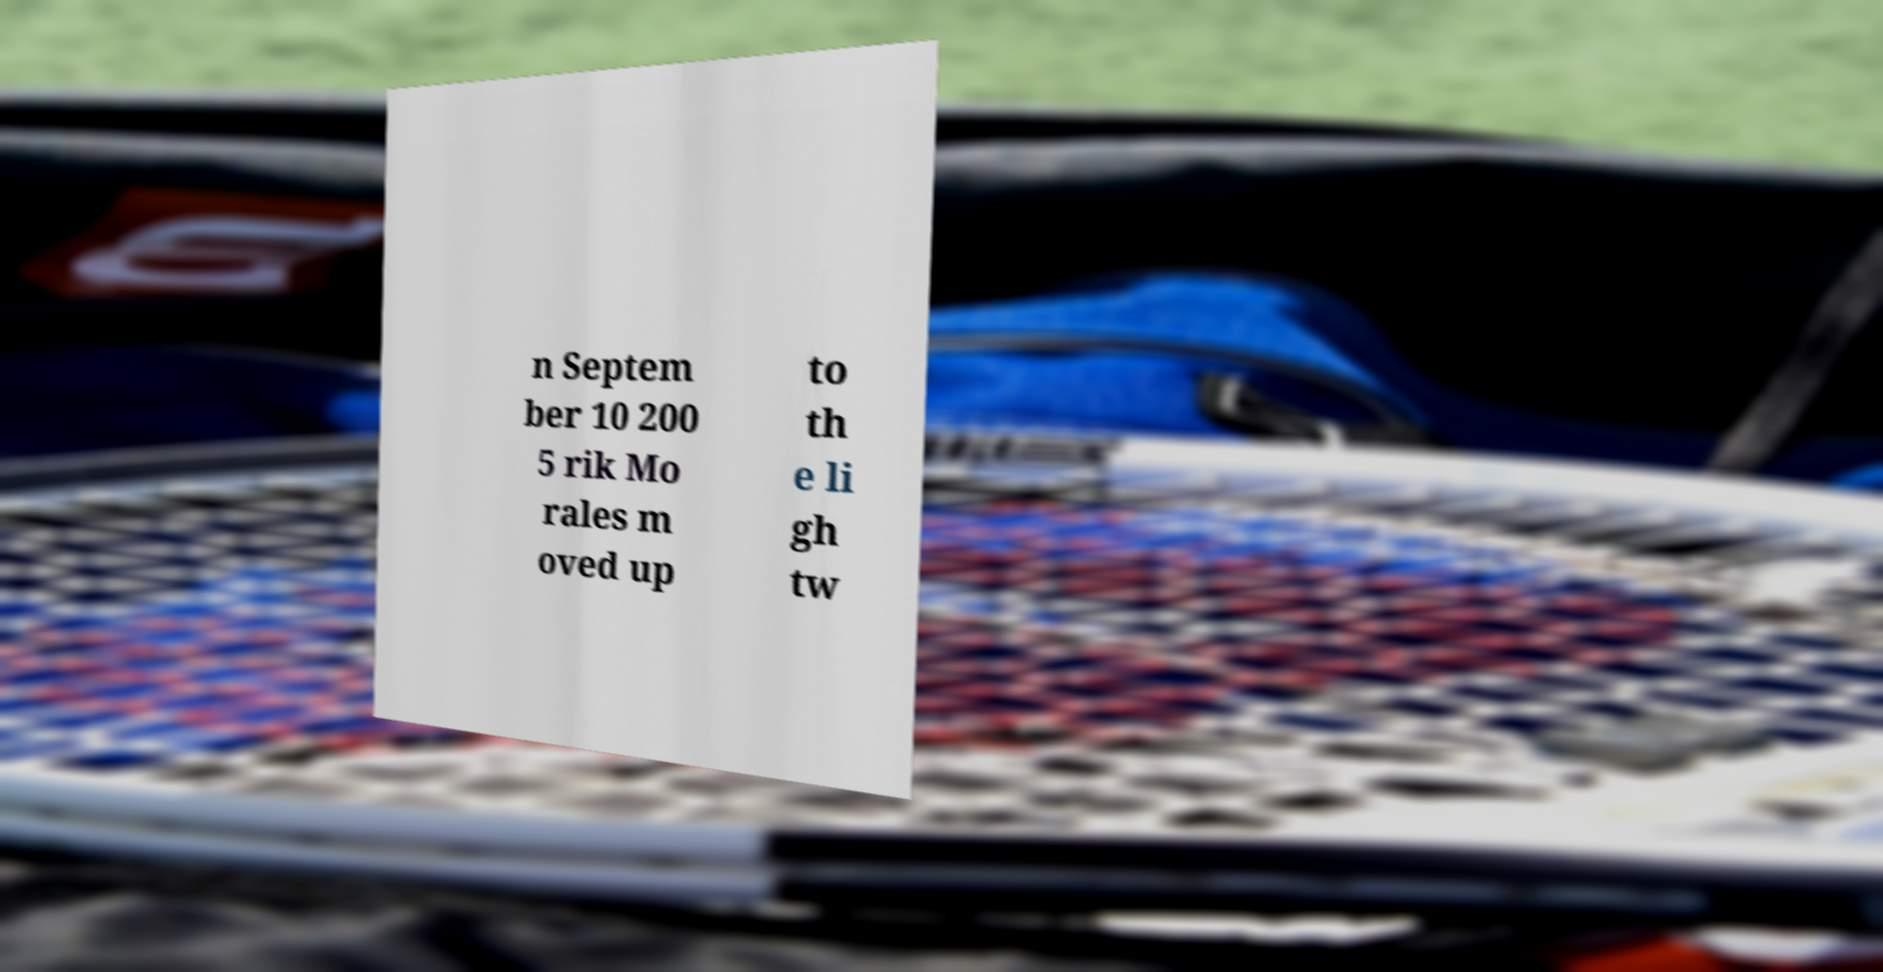There's text embedded in this image that I need extracted. Can you transcribe it verbatim? n Septem ber 10 200 5 rik Mo rales m oved up to th e li gh tw 